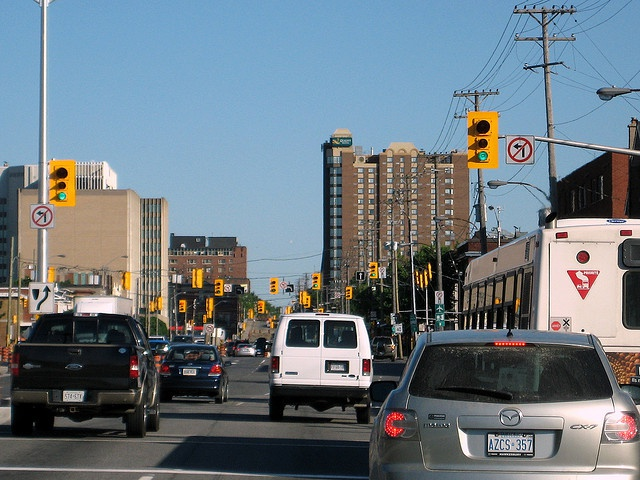Describe the objects in this image and their specific colors. I can see car in darkgray, black, gray, and lightgray tones, bus in darkgray, lightgray, black, and gray tones, truck in darkgray, black, gray, and maroon tones, car in darkgray, black, lightgray, and gray tones, and car in darkgray, black, gray, navy, and blue tones in this image. 